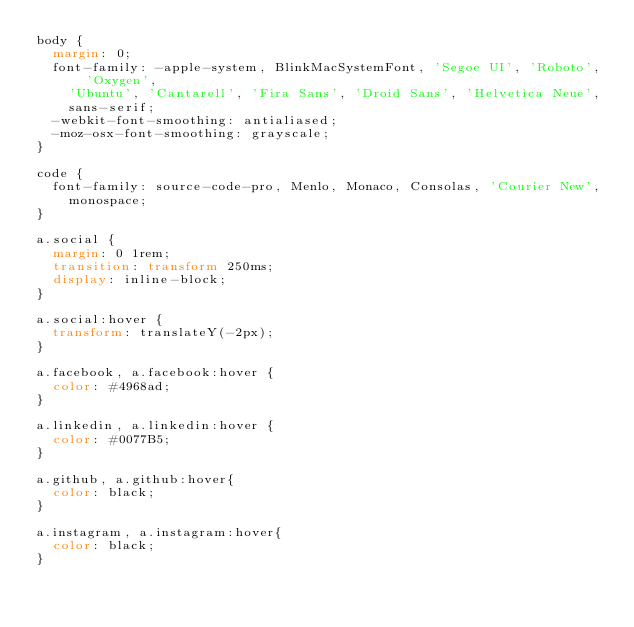Convert code to text. <code><loc_0><loc_0><loc_500><loc_500><_CSS_>body {
  margin: 0;
  font-family: -apple-system, BlinkMacSystemFont, 'Segoe UI', 'Roboto', 'Oxygen',
    'Ubuntu', 'Cantarell', 'Fira Sans', 'Droid Sans', 'Helvetica Neue',
    sans-serif;
  -webkit-font-smoothing: antialiased;
  -moz-osx-font-smoothing: grayscale;
}

code {
  font-family: source-code-pro, Menlo, Monaco, Consolas, 'Courier New',
    monospace;
}

a.social {
  margin: 0 1rem;
  transition: transform 250ms;
  display: inline-block;
}

a.social:hover {
  transform: translateY(-2px);
}

a.facebook, a.facebook:hover {
  color: #4968ad;
}

a.linkedin, a.linkedin:hover {
  color: #0077B5;
}

a.github, a.github:hover{
  color: black;
}

a.instagram, a.instagram:hover{
  color: black;
}</code> 